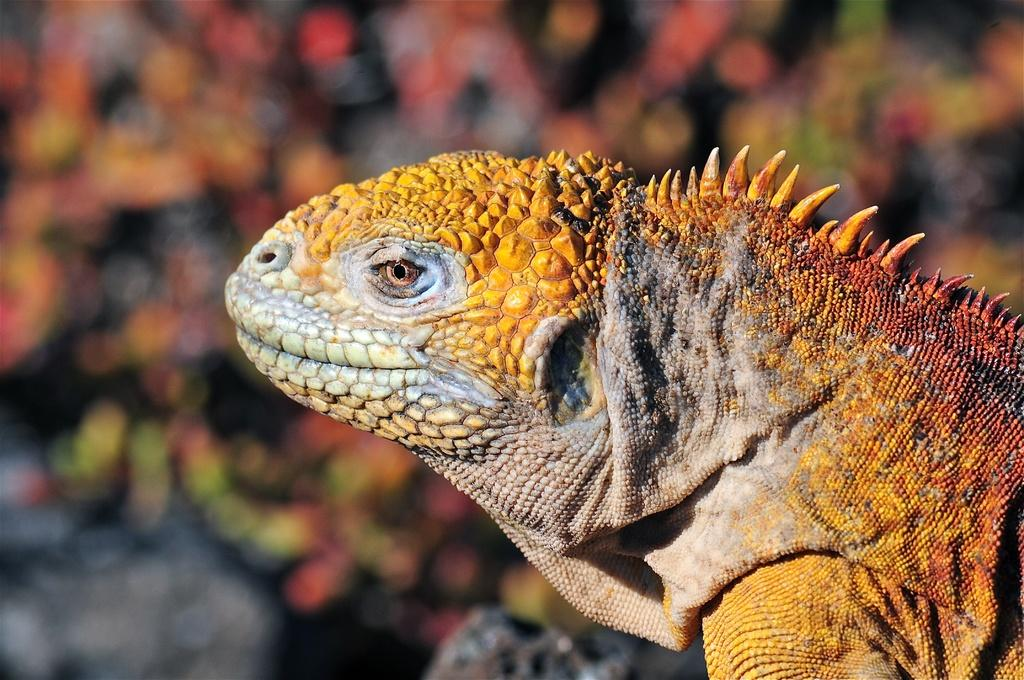What is the focus of the image? The image is zoomed in, so the focus is on a specific area or subject. Can you identify any living creature in the image? Yes, there is a reptile in the right corner of the image. What can be observed about the background of the image? The background of the image is blurred. What type of roof can be seen in the image? There is no roof present in the image. How many records can be seen in the image? There are no records visible in the image. 